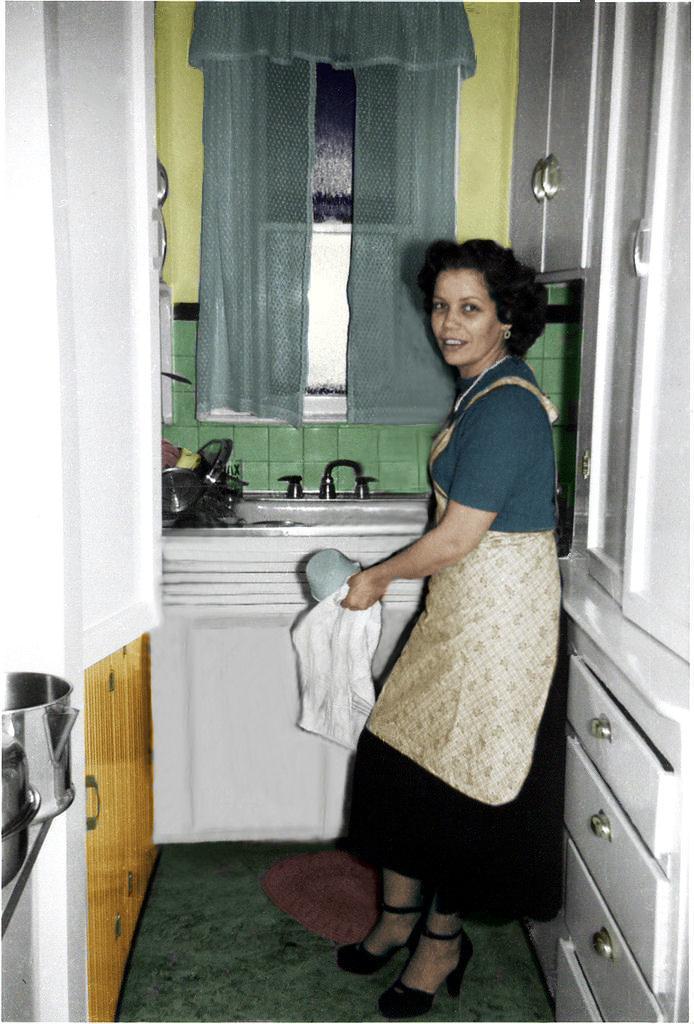How would you summarize this image in a sentence or two? In the image we can see a woman standing, wearing clothes, sandal and earring. The woman is holding an object in her hand, these are the containers, cupboards, window, curtains, floor, basin and a water tap. 